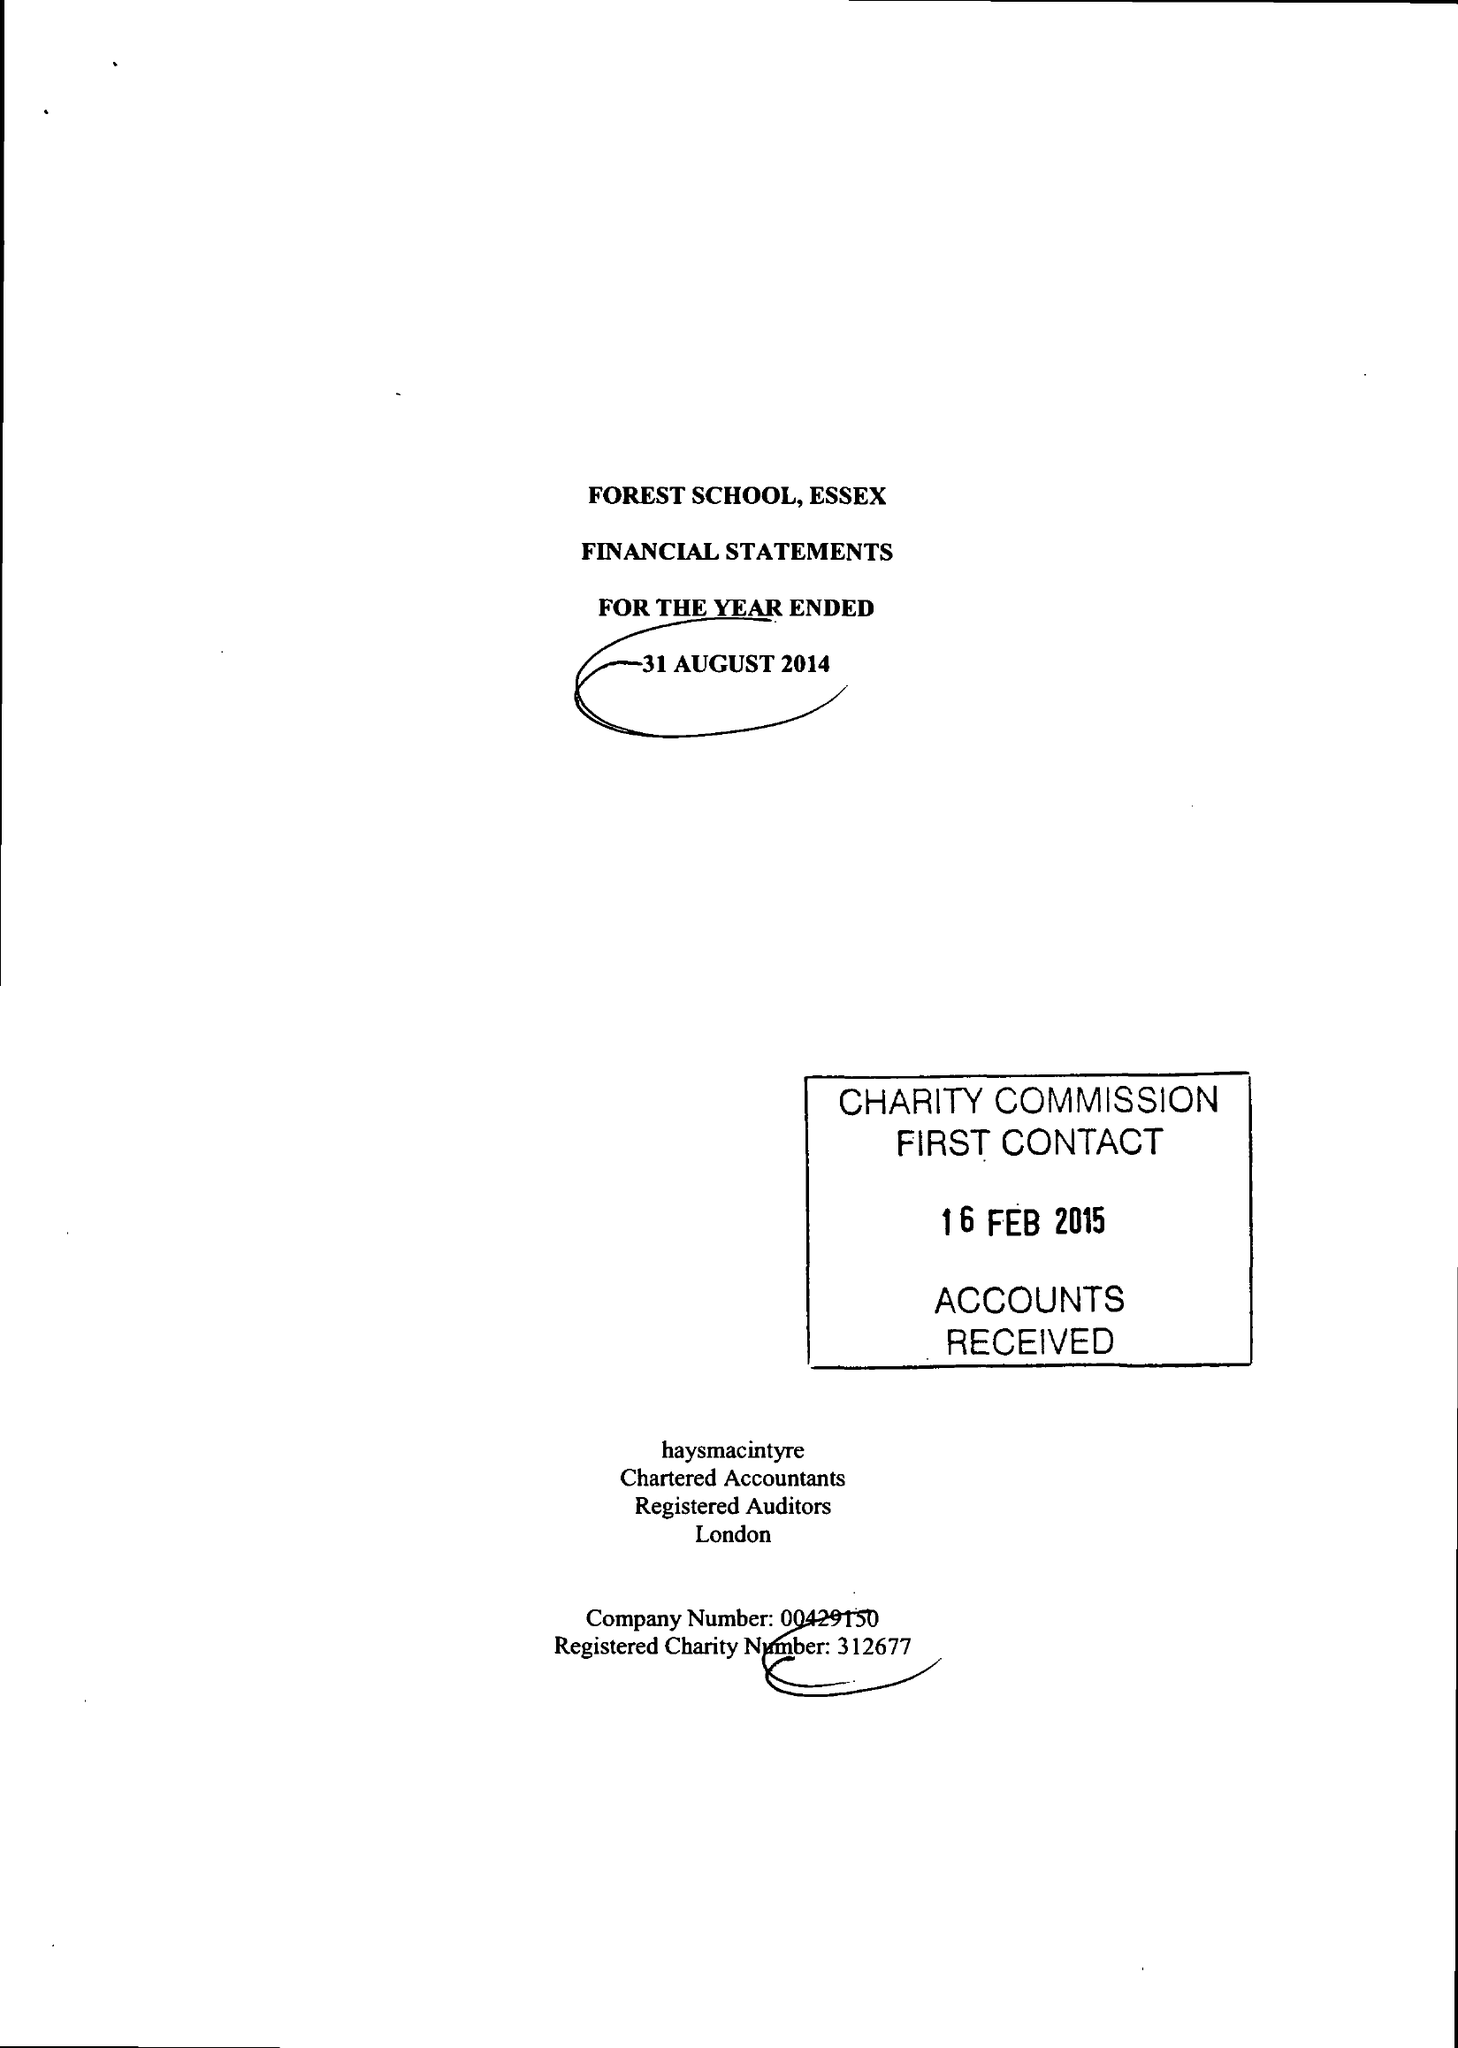What is the value for the spending_annually_in_british_pounds?
Answer the question using a single word or phrase. 17780195.00 